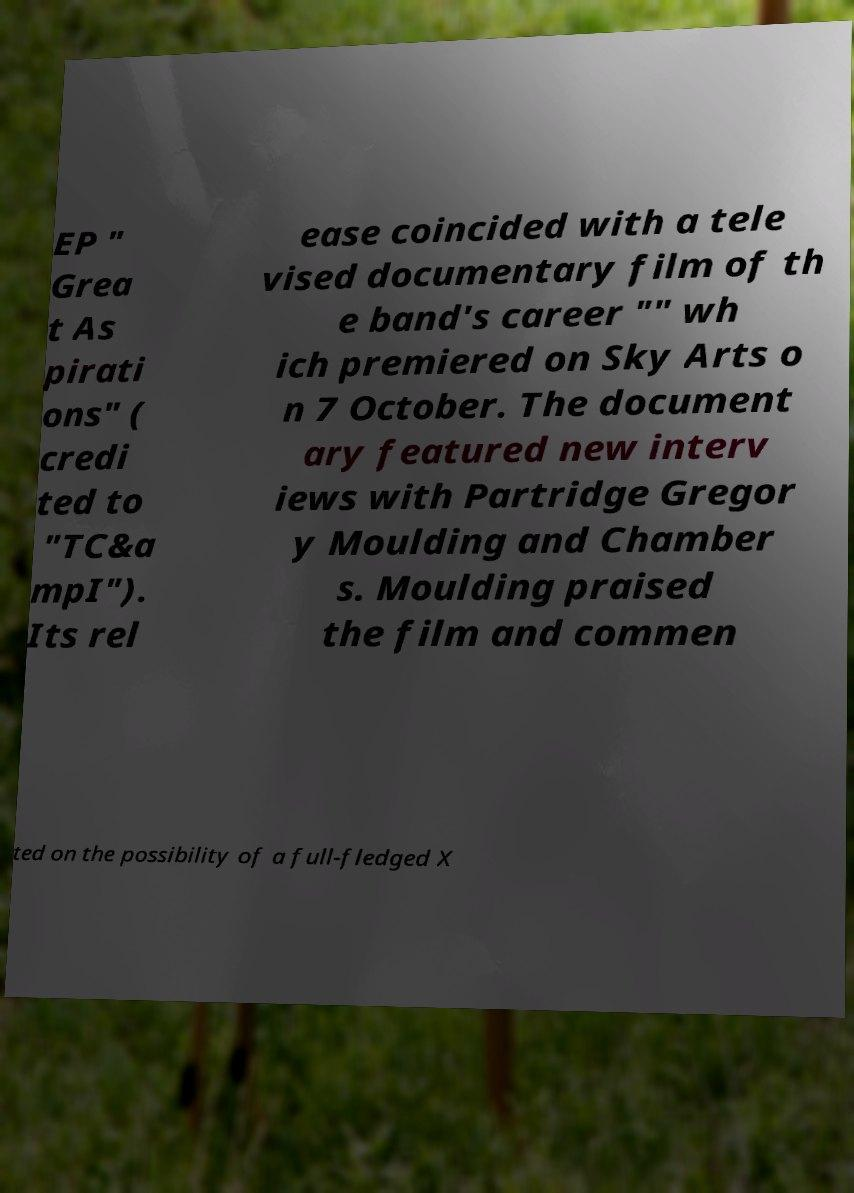For documentation purposes, I need the text within this image transcribed. Could you provide that? EP " Grea t As pirati ons" ( credi ted to "TC&a mpI"). Its rel ease coincided with a tele vised documentary film of th e band's career "" wh ich premiered on Sky Arts o n 7 October. The document ary featured new interv iews with Partridge Gregor y Moulding and Chamber s. Moulding praised the film and commen ted on the possibility of a full-fledged X 